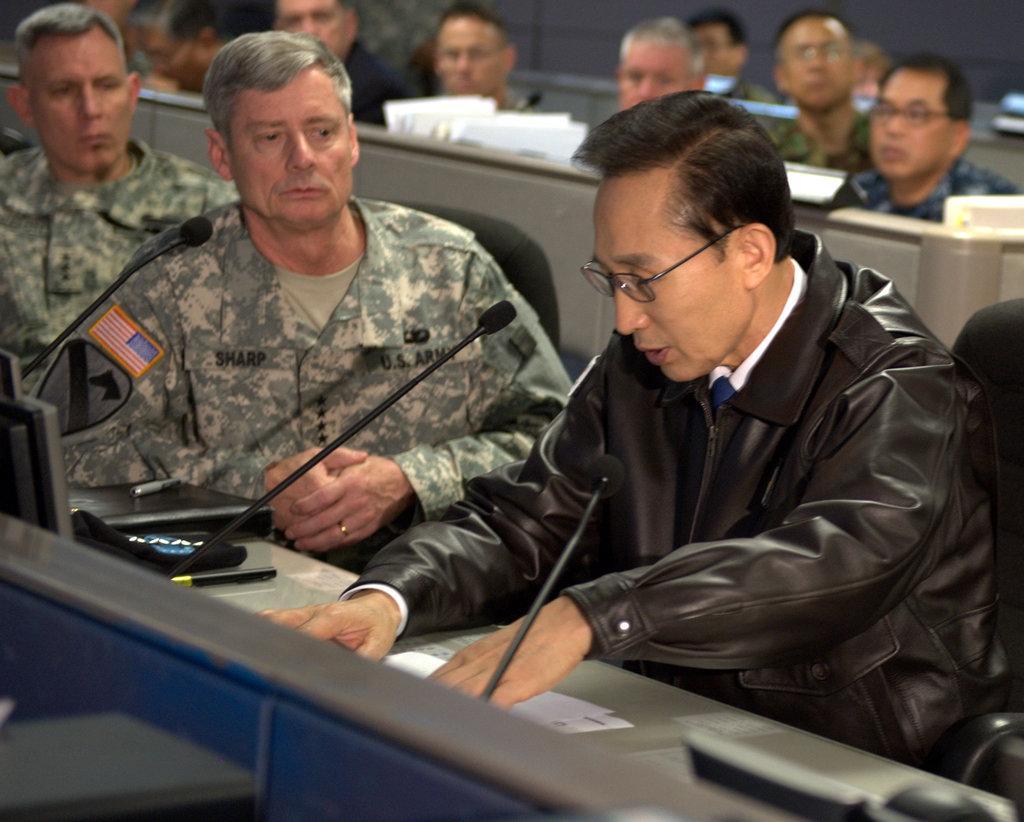In one or two sentences, can you explain what this image depicts? In this image I can see people are sitting on chairs. In-front of them there are tables, on the tables there are mice, papers and things. In the background of the image it is blurry.  